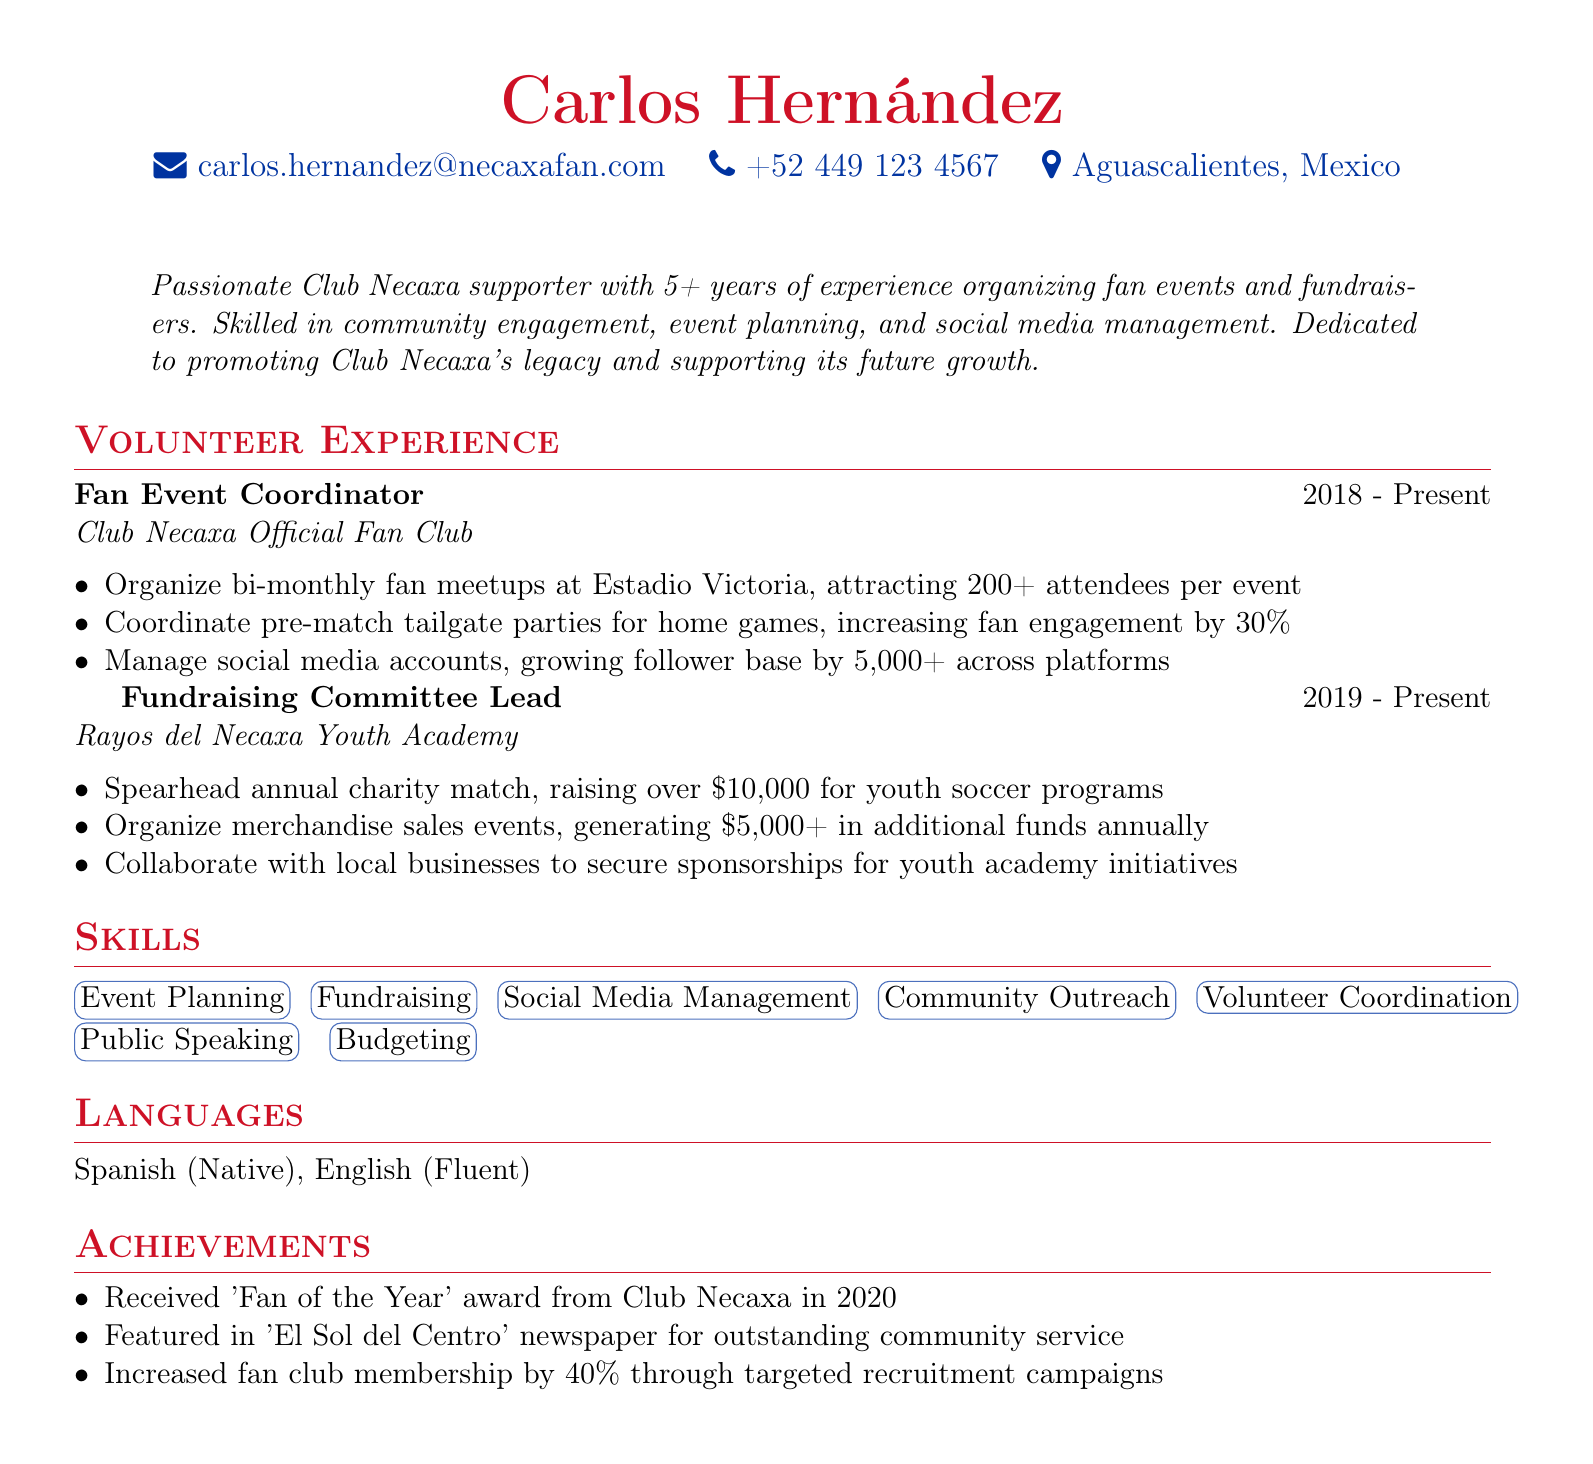what is the name of the candidate? The candidate's name is listed at the top of the document under contact information.
Answer: Carlos Hernández what is the primary role listed under volunteer experience? The primary role mentioned in the volunteer experience section is the title of the first position held.
Answer: Fan Event Coordinator how many years of experience does Carlos have organizing fan events? The summary states the total years of experience in organizing fan events.
Answer: 5+ years what significant achievement did Carlos receive in 2020? An award received in recognition of outstanding support towards the Club Necaxa community.
Answer: 'Fan of the Year' how much money has Carlos raised through the annual charity match? The specific amount raised through the annual charity match is explicitly stated.
Answer: over $10,000 what increase in fan engagement did Carlos achieve through tailgate parties? The percentage increase in fan engagement due to the tailgate parties is detailed.
Answer: 30% how many attendees are typically attracted to the bi-monthly meetups? The number of attendees mentioned for the bi-monthly meetups organized by Carlos.
Answer: 200+ which languages does Carlos speak? The languages Carlos mentions in the document under the language section.
Answer: Spanish, English how much revenue is generated annually from merchandise sales events? The total revenue generated from merchandise sales according to the document.
Answer: $5,000+ 